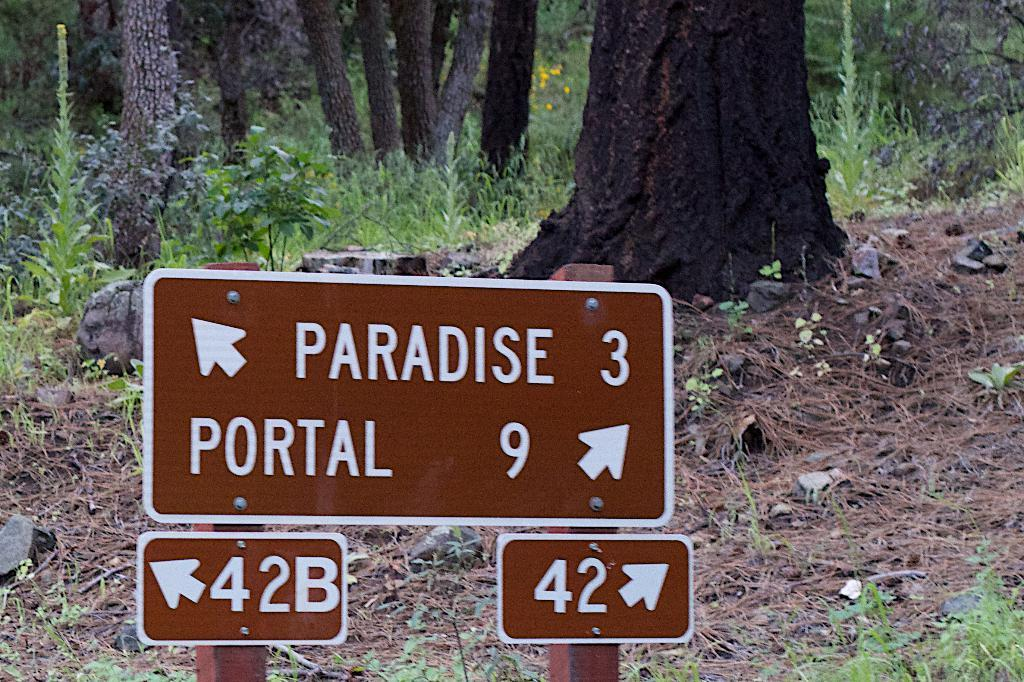What is located in the center of the image? There are sign boards in the center of the image. What type of natural environment is visible in the background of the image? There is grass, stones, trees, and plants in the background of the image. What type of birthday celebration is depicted in the image? There is no birthday celebration depicted in the image; it features sign boards and a natural background. What shape is the flag in the image? There is no flag present in the image. 